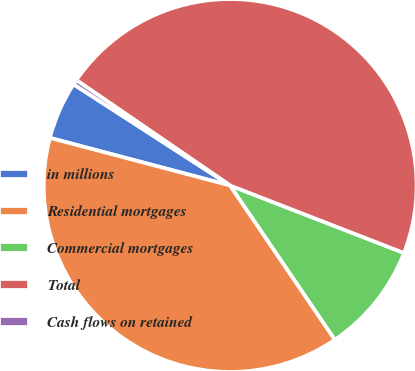<chart> <loc_0><loc_0><loc_500><loc_500><pie_chart><fcel>in millions<fcel>Residential mortgages<fcel>Commercial mortgages<fcel>Total<fcel>Cash flows on retained<nl><fcel>5.02%<fcel>38.6%<fcel>9.61%<fcel>46.32%<fcel>0.43%<nl></chart> 